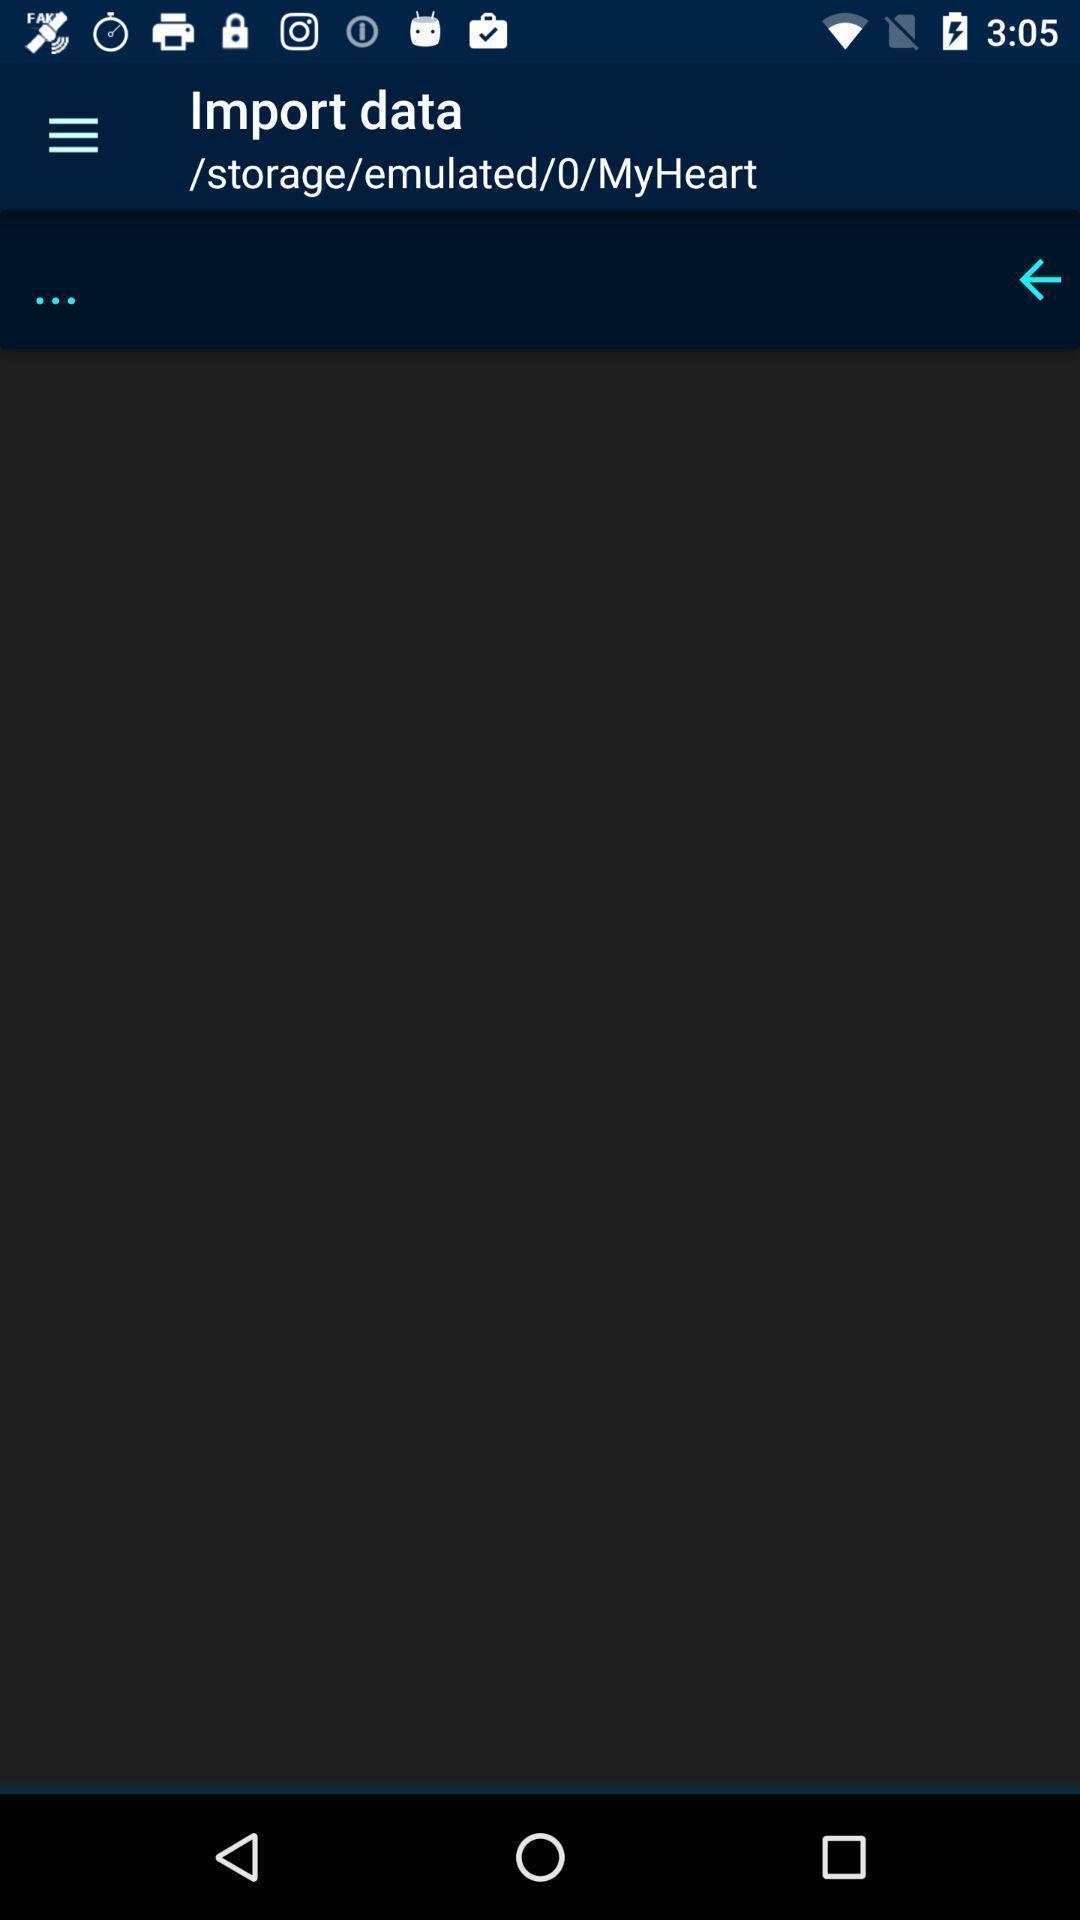What details can you identify in this image? Screen showing import date page. 